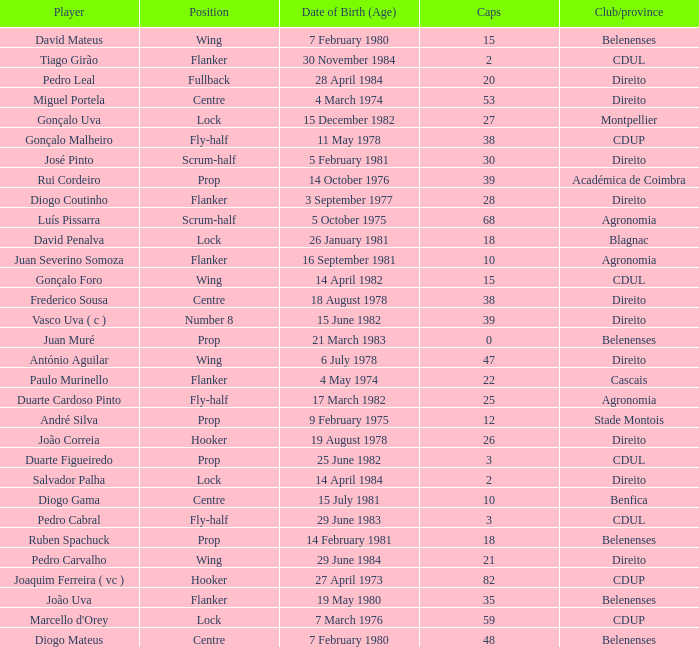How many caps have a Position of prop, and a Player of rui cordeiro? 1.0. 